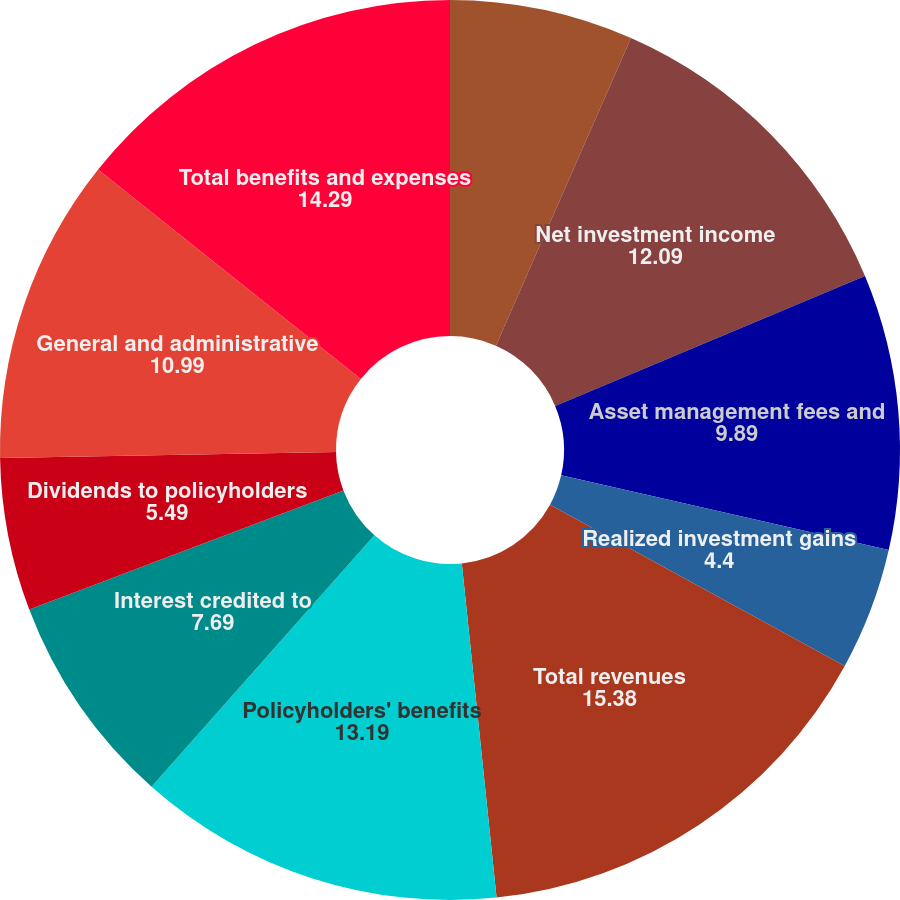<chart> <loc_0><loc_0><loc_500><loc_500><pie_chart><fcel>Policy charges and fee income<fcel>Net investment income<fcel>Asset management fees and<fcel>Realized investment gains<fcel>Total revenues<fcel>Policyholders' benefits<fcel>Interest credited to<fcel>Dividends to policyholders<fcel>General and administrative<fcel>Total benefits and expenses<nl><fcel>6.59%<fcel>12.09%<fcel>9.89%<fcel>4.4%<fcel>15.38%<fcel>13.19%<fcel>7.69%<fcel>5.49%<fcel>10.99%<fcel>14.29%<nl></chart> 